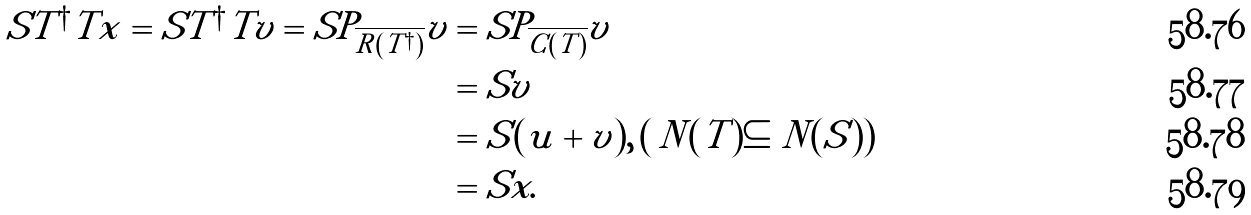<formula> <loc_0><loc_0><loc_500><loc_500>S T ^ { \dagger } T x = S T ^ { \dagger } T v = S P _ { \overline { R ( T ^ { \dagger } ) } } v & = S P _ { \overline { C ( T ) } } v \\ & = S v \\ & = S ( u + v ) , \, ( \, N ( T ) \subseteq N ( S ) ) \\ & = S x .</formula> 